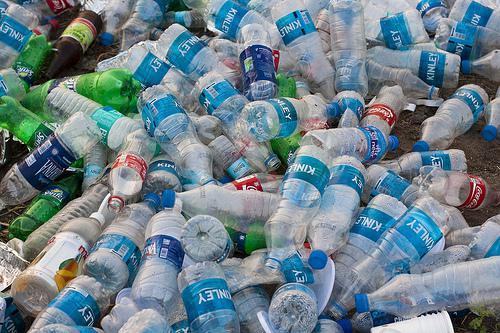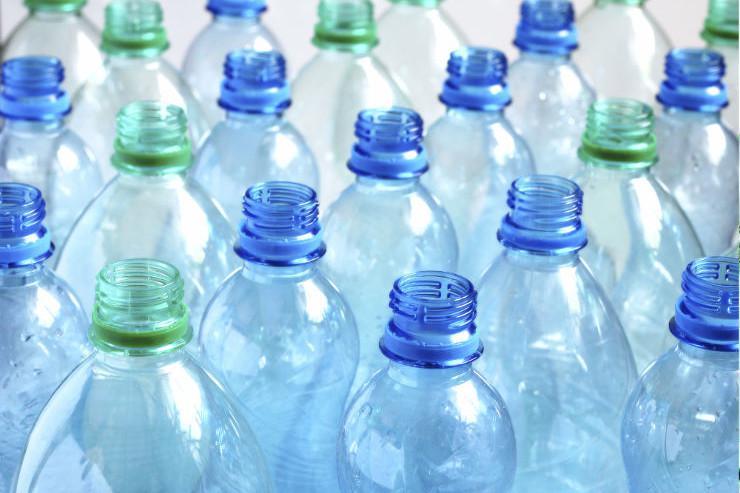The first image is the image on the left, the second image is the image on the right. Assess this claim about the two images: "At least one image shows all bottles with white caps.". Correct or not? Answer yes or no. No. The first image is the image on the left, the second image is the image on the right. Assess this claim about the two images: "In at least one image, bottles are capped with only white lids.". Correct or not? Answer yes or no. No. 